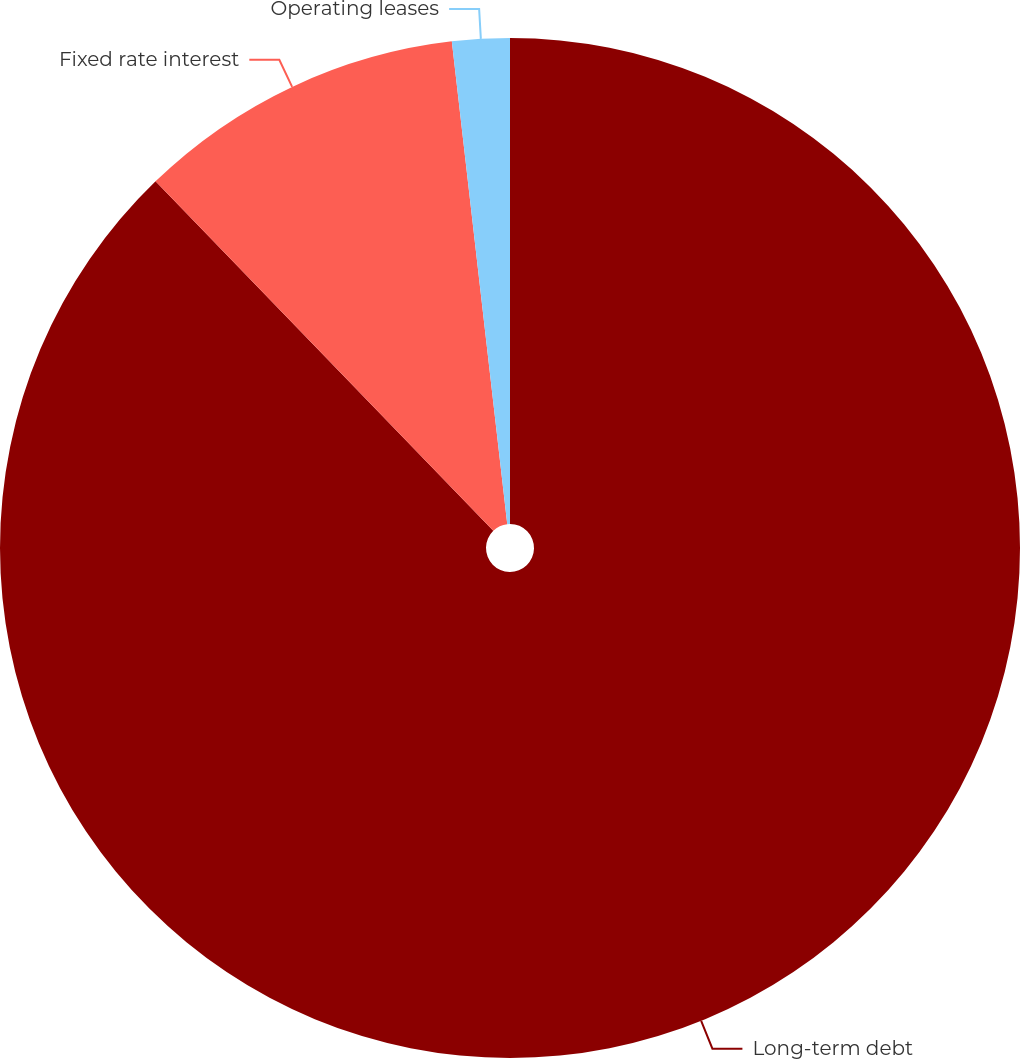Convert chart to OTSL. <chart><loc_0><loc_0><loc_500><loc_500><pie_chart><fcel>Long-term debt<fcel>Fixed rate interest<fcel>Operating leases<nl><fcel>87.77%<fcel>10.41%<fcel>1.82%<nl></chart> 